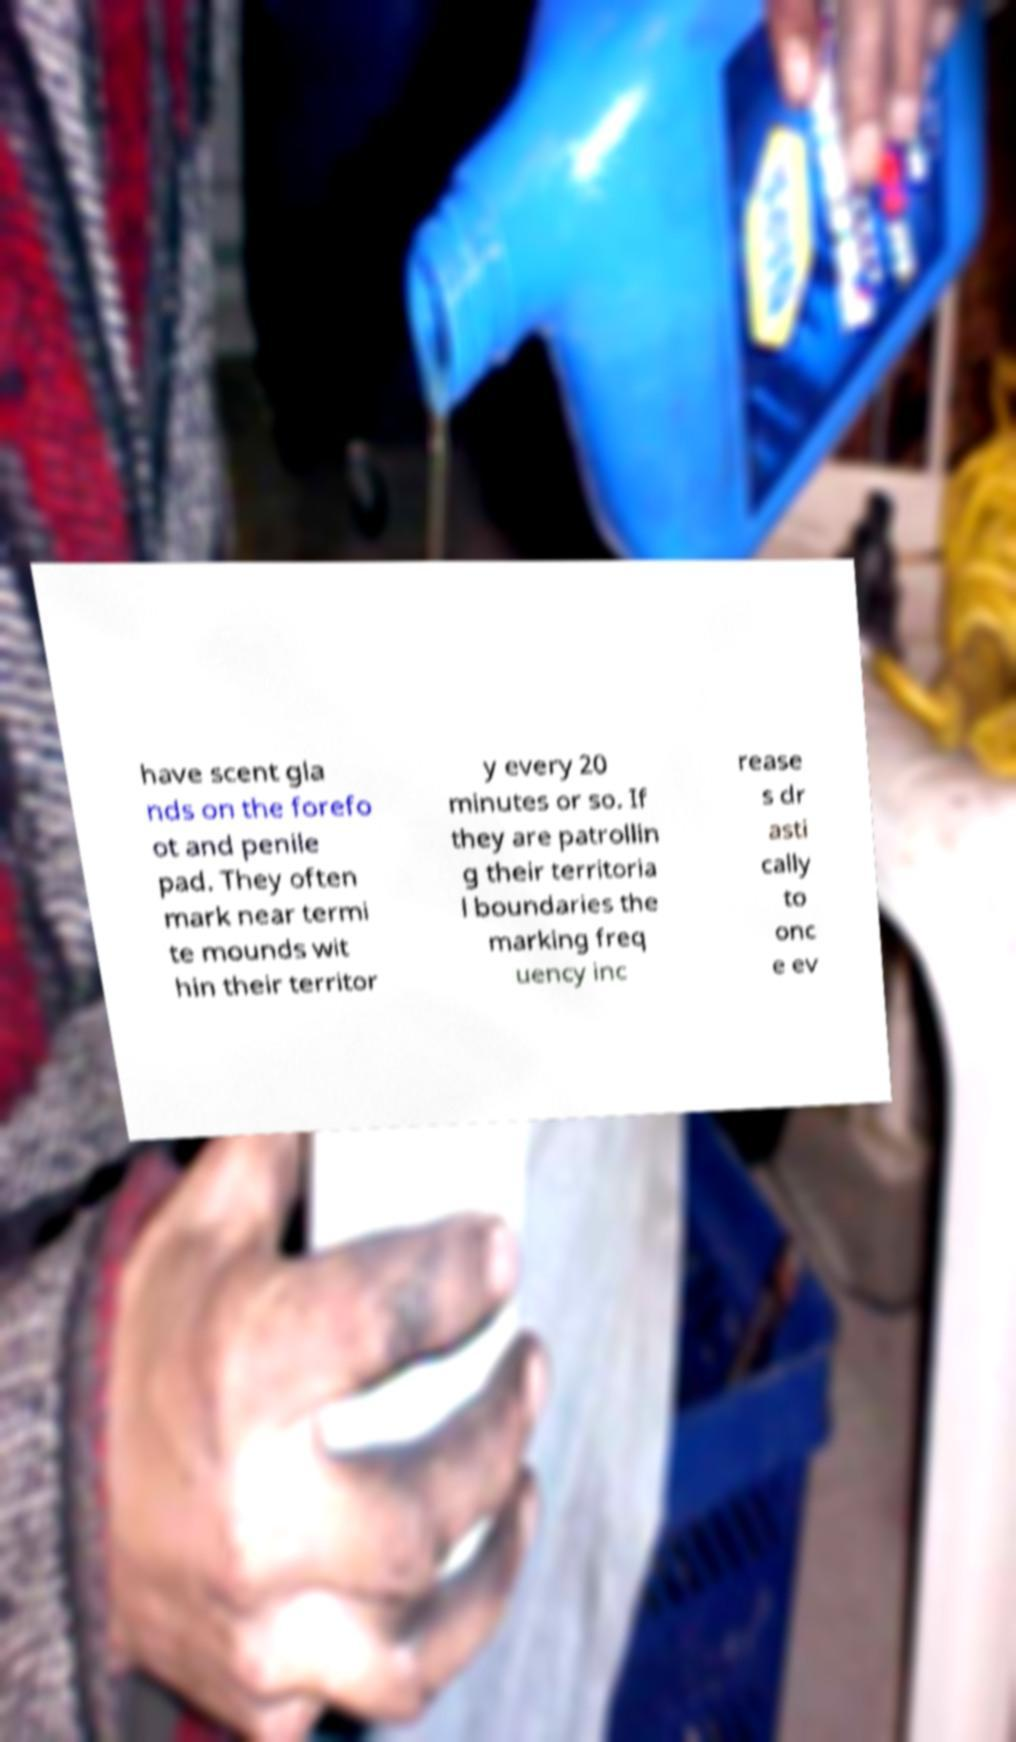Can you read and provide the text displayed in the image?This photo seems to have some interesting text. Can you extract and type it out for me? have scent gla nds on the forefo ot and penile pad. They often mark near termi te mounds wit hin their territor y every 20 minutes or so. If they are patrollin g their territoria l boundaries the marking freq uency inc rease s dr asti cally to onc e ev 